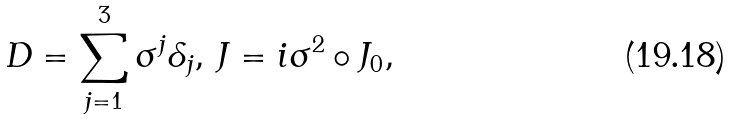Convert formula to latex. <formula><loc_0><loc_0><loc_500><loc_500>D = \sum _ { j = 1 } ^ { 3 } \sigma ^ { j } \delta _ { j } , \, J = i \sigma ^ { 2 } \circ J _ { 0 } ,</formula> 